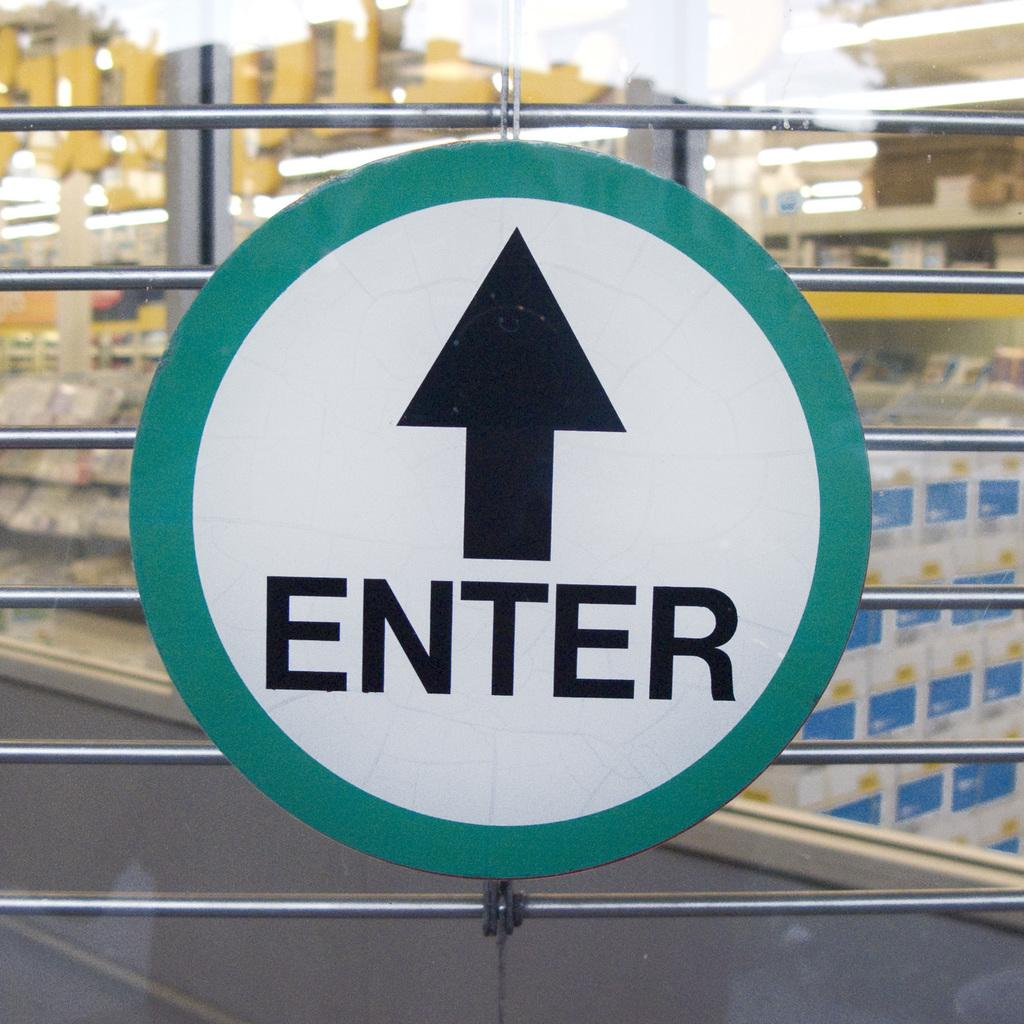Provide a one-sentence caption for the provided image. A greena nd black sign on a gate saying enter with an arrow pointing ahead. 